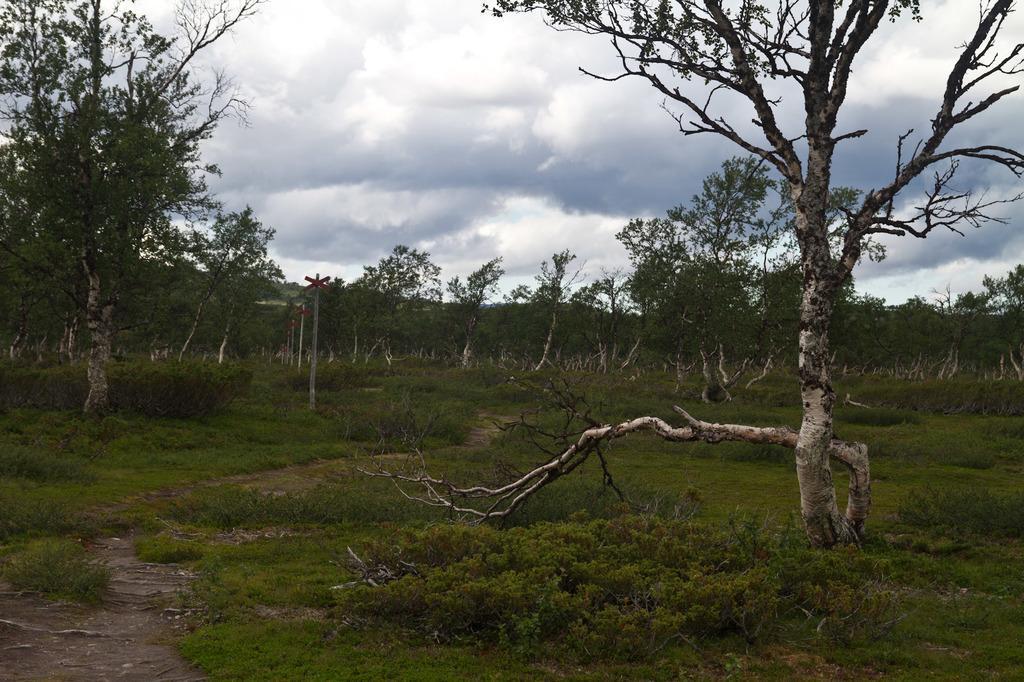Can you describe this image briefly? In this image we can see there are some trees, plants and grass on the surface of the area. In the background there is a sky. 